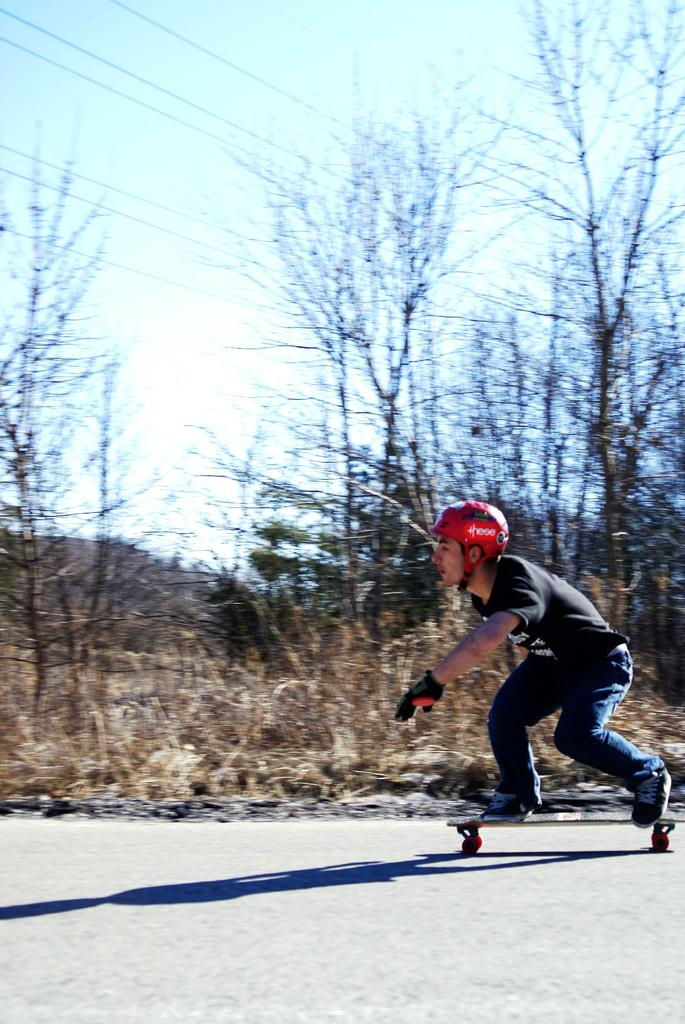What is the main subject of the image? There is a person in the image. What is the person doing in the image? The person is on a skateboard. What safety gear is the person wearing? The person is wearing a helmet. What can be seen in the background of the image? There are trees, wires, and the sky visible in the background of the image. What type of shirt is the person wearing in the image? The provided facts do not mention the type of shirt the person is wearing. --- Facts: 1. There is a car in the image. 2. The car is red. 3. The car has four wheels. 4. There are people in the car. 5. The car is parked on the street. Absurd Topics: parrot, dance, ocean Conversation: What is the main subject of the image? There is a car in the image. What color is the car? The car is red. How many wheels does the car have? The car has four wheels. Are there any passengers in the car? Yes, there are people in the car. Where is the car located in the image? The car is parked on the street. Reasoning: Let's think step by step in order to produce the conversation. We start by identifying the main subject of the image, which is the car.    Then, we describe the color and number of wheels of the car. Next, we mention the presence of passengers in the car. Finally, we describe the location of the car, which is parked on the street. Absurd Question/Answer: Can you see a parrot dancing in the ocean in the image? No, there is no parrot dancing in the ocean in the image. 